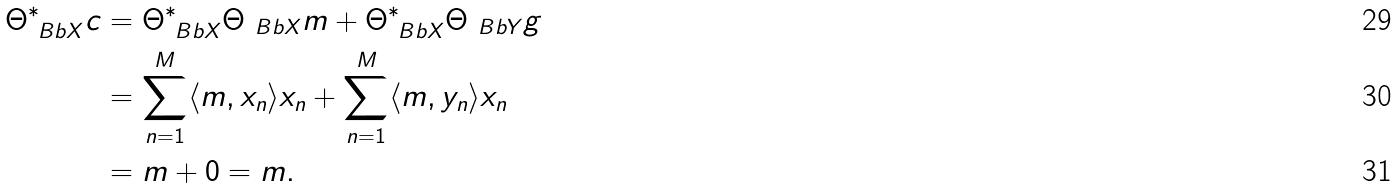Convert formula to latex. <formula><loc_0><loc_0><loc_500><loc_500>\Theta _ { \ B b { X } } ^ { * } c & = \Theta _ { \ B b { X } } ^ { * } \Theta _ { \ B b { X } } m + \Theta _ { \ B b { X } } ^ { * } \Theta _ { \ B b { Y } } g \\ & = \sum _ { n = 1 } ^ { M } \langle m , x _ { n } \rangle x _ { n } + \sum _ { n = 1 } ^ { M } \langle m , y _ { n } \rangle x _ { n } \\ & = m + 0 = m .</formula> 